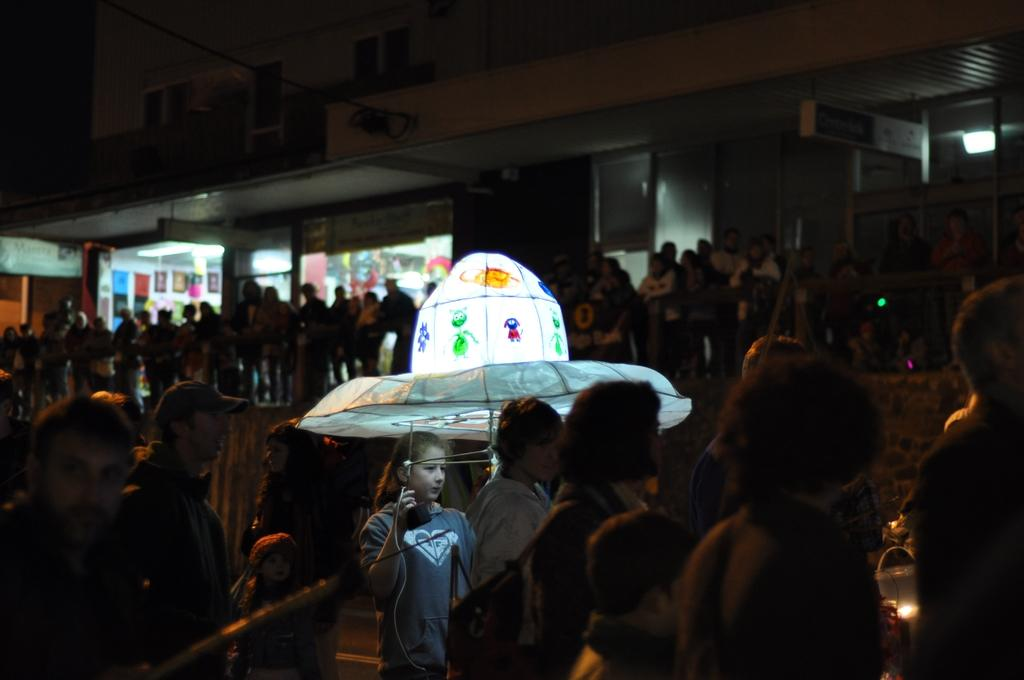What are the people in the image doing? The persons in the image are standing on the stairs. What type of establishments can be seen in the image? There are stores in the image. What structure is visible in the image? There is a building in the image. What type of treatment is being administered to the pot during the rainstorm in the image? There is no pot or rainstorm present in the image, so it is not possible to answer that question. 